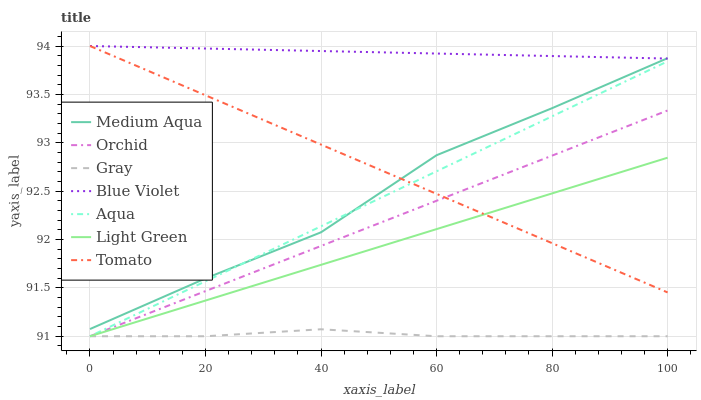Does Gray have the minimum area under the curve?
Answer yes or no. Yes. Does Blue Violet have the maximum area under the curve?
Answer yes or no. Yes. Does Aqua have the minimum area under the curve?
Answer yes or no. No. Does Aqua have the maximum area under the curve?
Answer yes or no. No. Is Aqua the smoothest?
Answer yes or no. Yes. Is Medium Aqua the roughest?
Answer yes or no. Yes. Is Gray the smoothest?
Answer yes or no. No. Is Gray the roughest?
Answer yes or no. No. Does Gray have the lowest value?
Answer yes or no. Yes. Does Medium Aqua have the lowest value?
Answer yes or no. No. Does Blue Violet have the highest value?
Answer yes or no. Yes. Does Aqua have the highest value?
Answer yes or no. No. Is Orchid less than Blue Violet?
Answer yes or no. Yes. Is Blue Violet greater than Light Green?
Answer yes or no. Yes. Does Medium Aqua intersect Aqua?
Answer yes or no. Yes. Is Medium Aqua less than Aqua?
Answer yes or no. No. Is Medium Aqua greater than Aqua?
Answer yes or no. No. Does Orchid intersect Blue Violet?
Answer yes or no. No. 